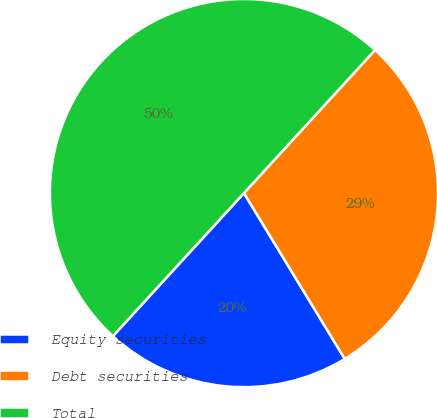Convert chart. <chart><loc_0><loc_0><loc_500><loc_500><pie_chart><fcel>Equity securities<fcel>Debt securities<fcel>Total<nl><fcel>20.5%<fcel>29.5%<fcel>50.0%<nl></chart> 